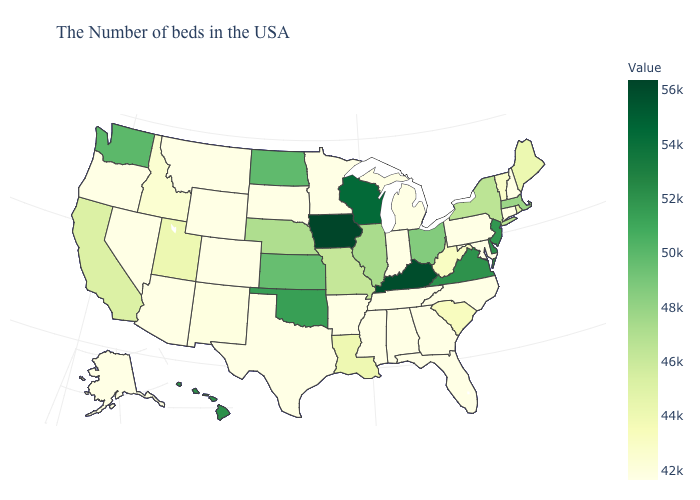Among the states that border Arkansas , does Missouri have the lowest value?
Short answer required. No. Which states hav the highest value in the West?
Quick response, please. Hawaii. Which states hav the highest value in the South?
Short answer required. Kentucky. Which states have the highest value in the USA?
Write a very short answer. Iowa. Does Louisiana have the lowest value in the USA?
Short answer required. No. 